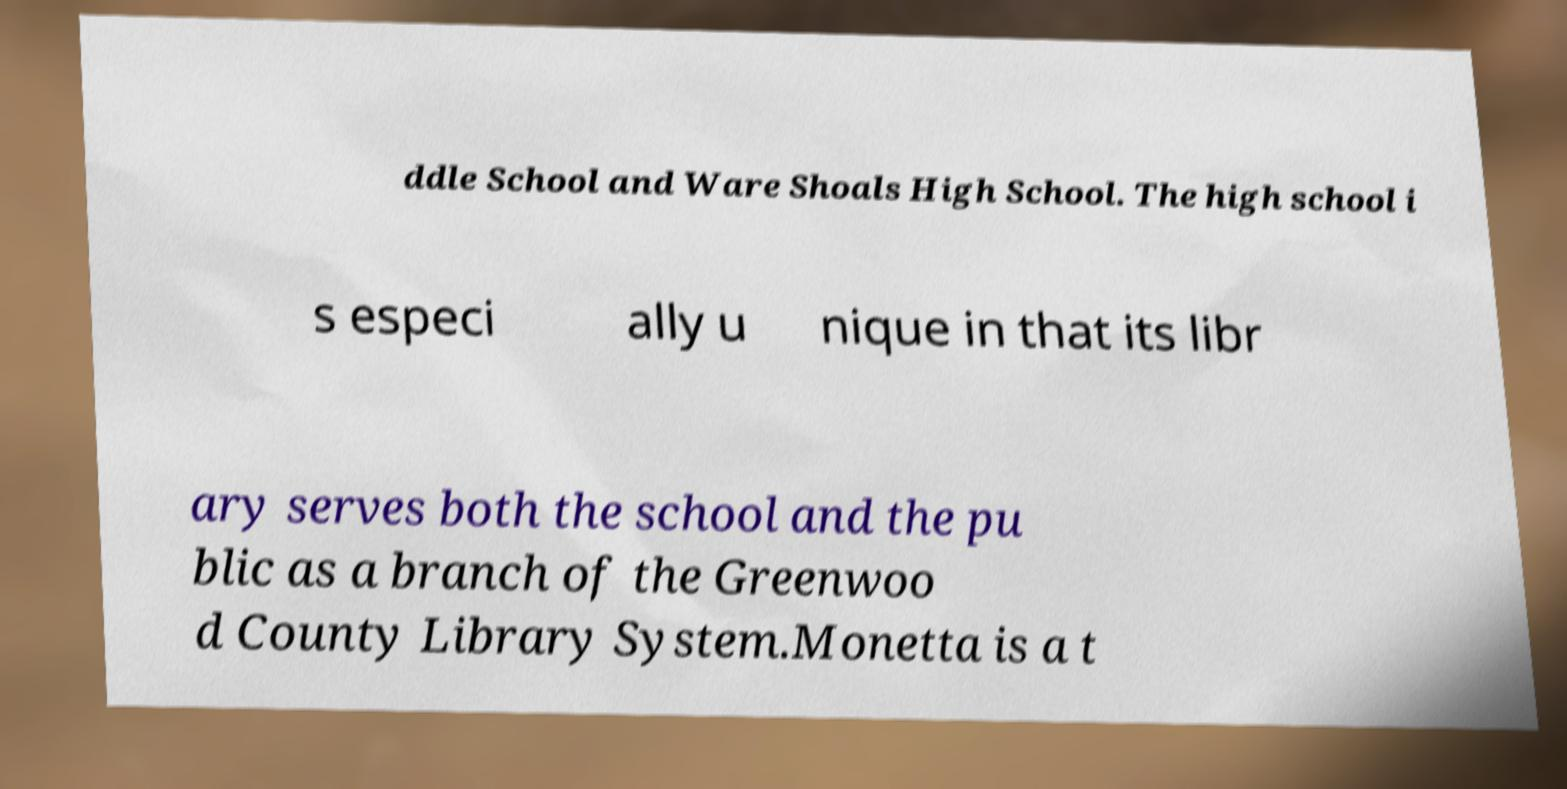There's text embedded in this image that I need extracted. Can you transcribe it verbatim? ddle School and Ware Shoals High School. The high school i s especi ally u nique in that its libr ary serves both the school and the pu blic as a branch of the Greenwoo d County Library System.Monetta is a t 